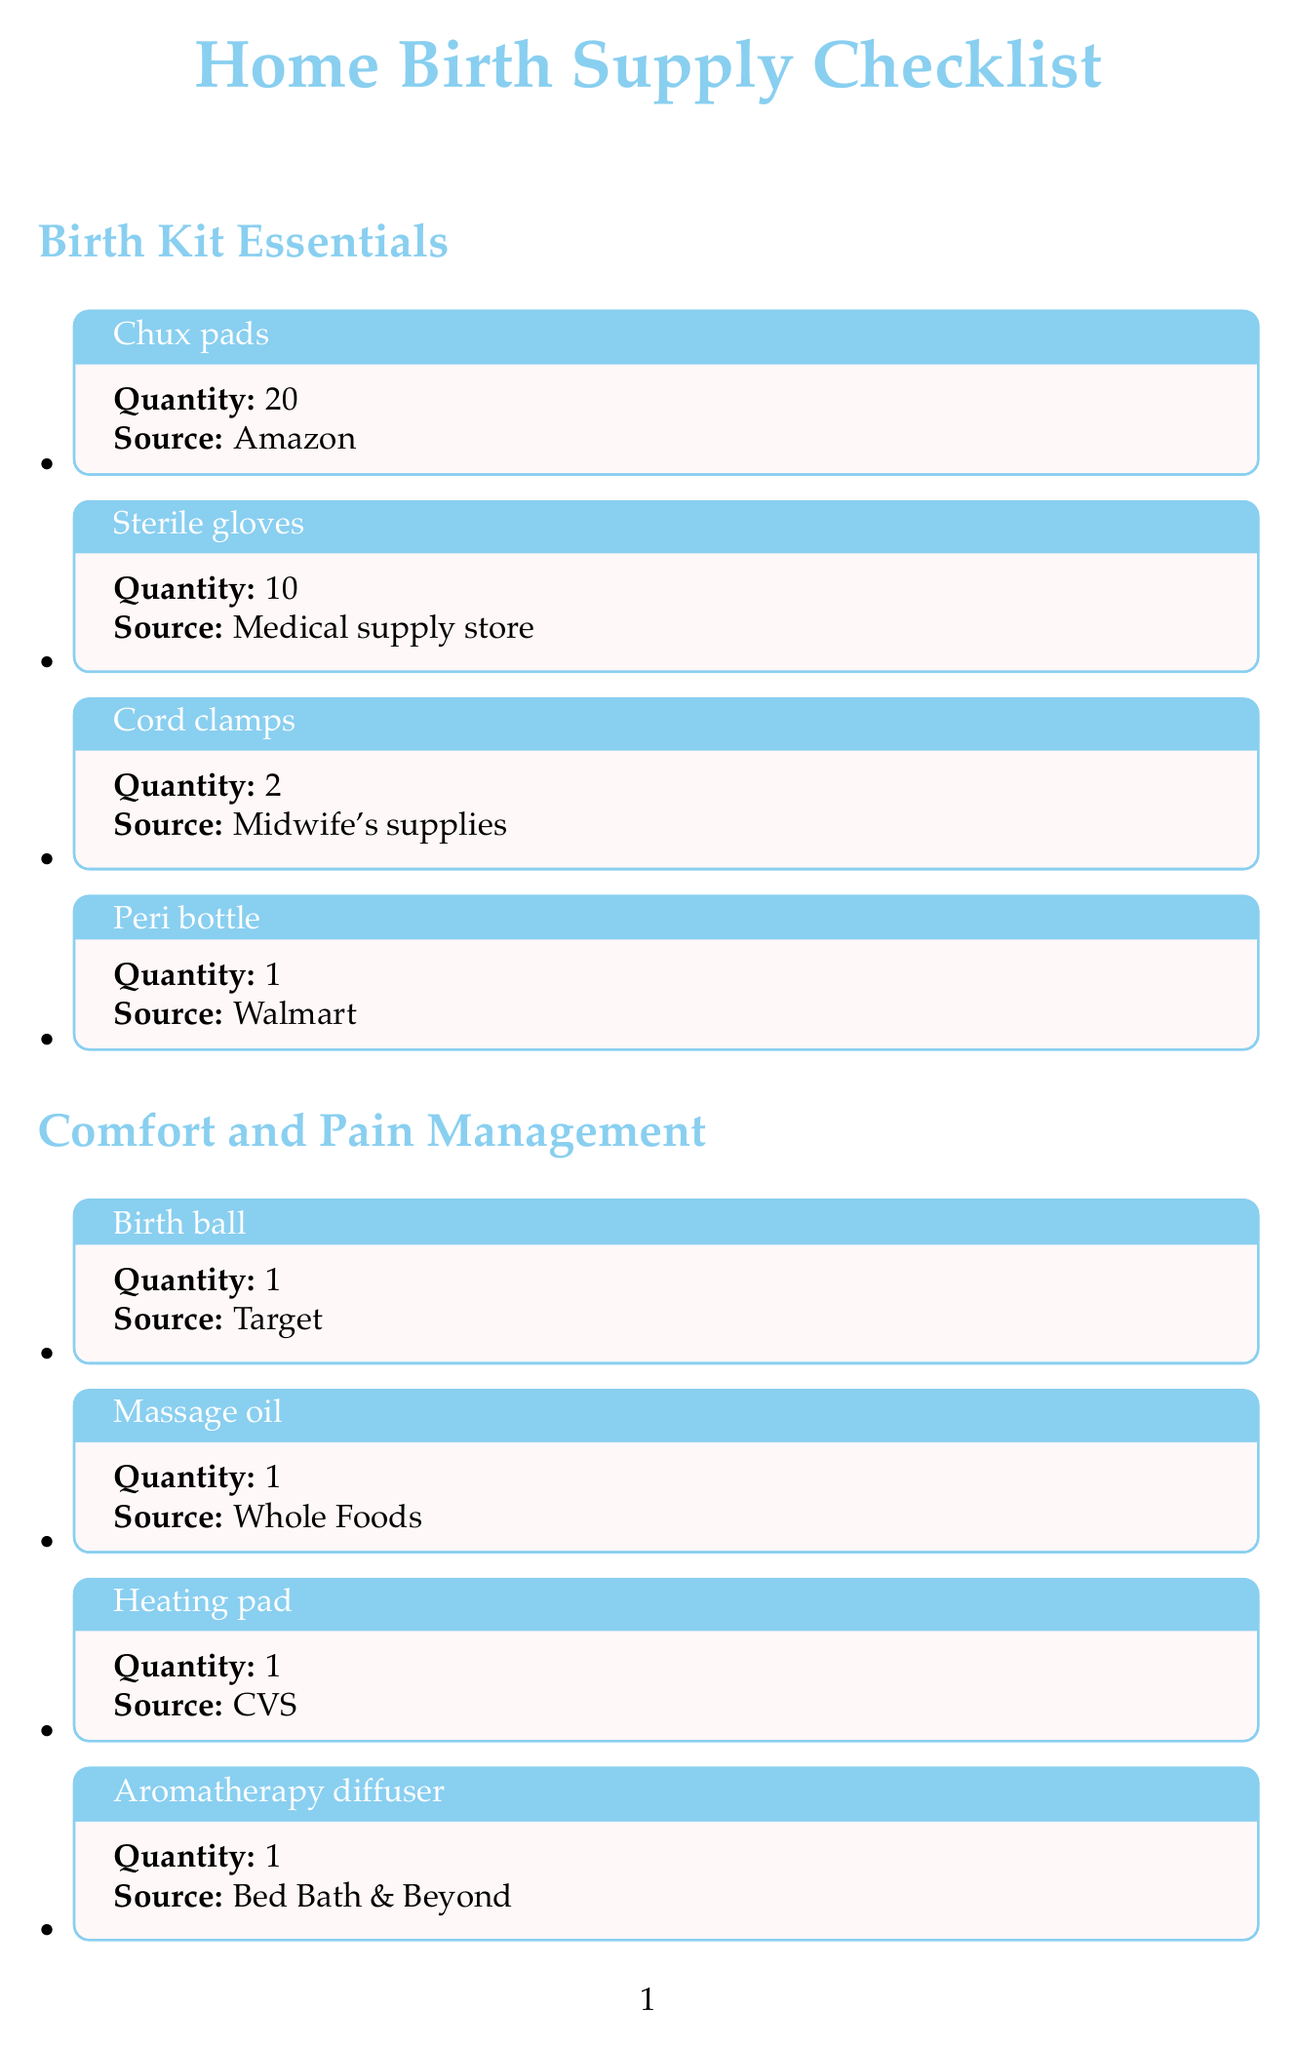What is the quantity of Chux pads? The document states the quantity of Chux pads is given as 20.
Answer: 20 Where can you find the birth pool? The source for the birth pool is listed as La Bassine in the document.
Answer: La Bassine How many quantities of maternity pads are needed? The document specifies the quantity of maternity pads required is 2.
Answer: 2 Which store provides sterile gloves? The source mentioned in the document for sterile gloves is a medical supply store.
Answer: Medical supply store What is the total quantity of energy bars? The document indicates that the total quantity of energy bars needed is 10.
Answer: 10 How many LED candles are on the list? The document mentions that there are 6 LED candles included in the checklist.
Answer: 6 What type of pain management item is listed from Whole Foods? The document lists massage oil as the pain management item from Whole Foods.
Answer: Massage oil Which section includes newborn diapers? The newborn diapers are listed under the Baby Care section in the document.
Answer: Baby Care What item is recommended for postpartum care to provide cooling relief? Perineal ice packs are recommended for cooling relief in the postpartum care section in the document.
Answer: Perineal ice packs 